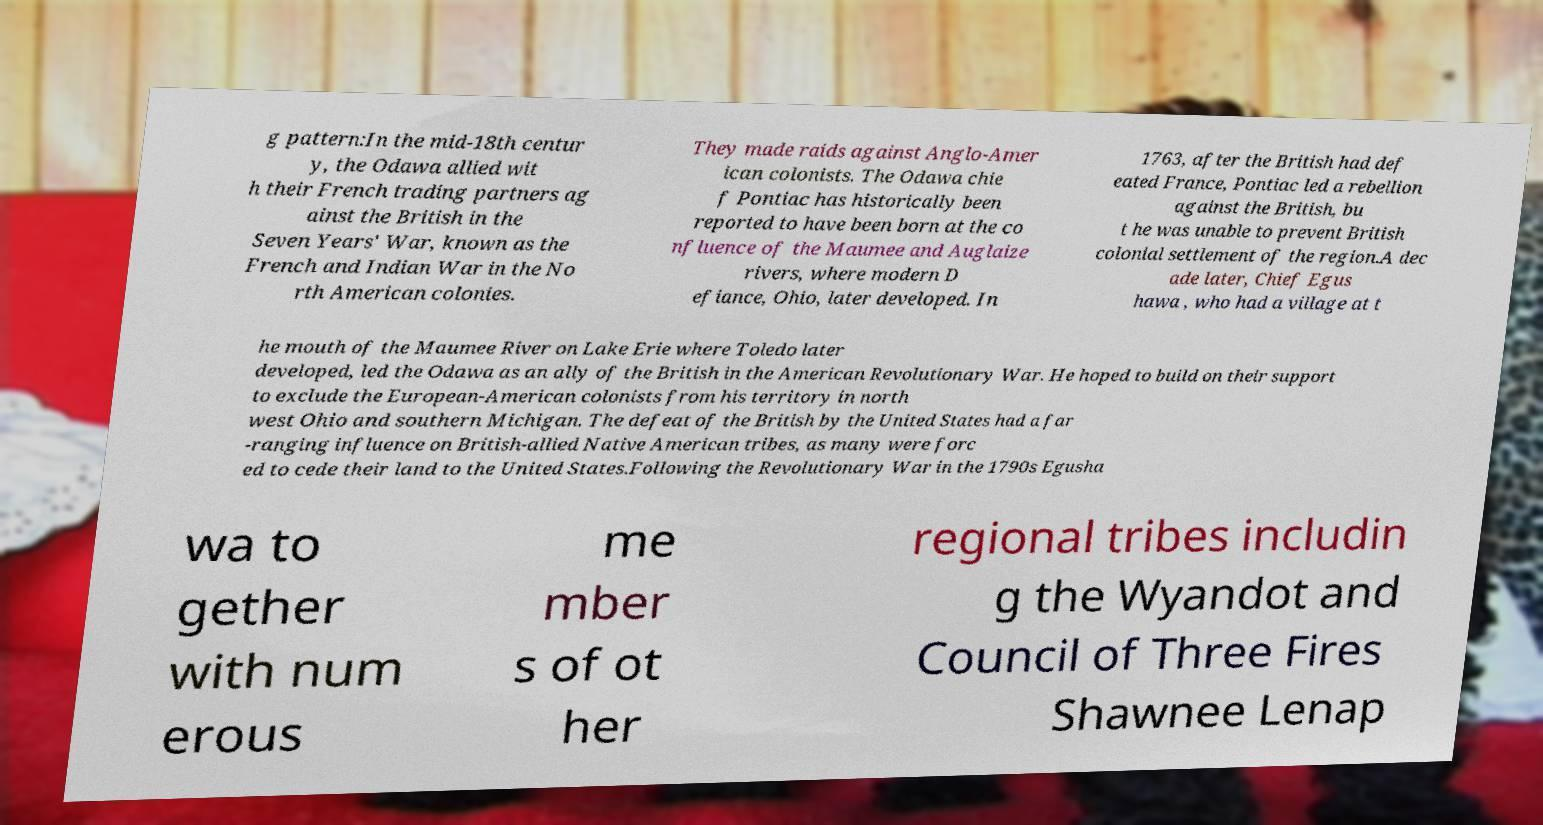There's text embedded in this image that I need extracted. Can you transcribe it verbatim? g pattern:In the mid-18th centur y, the Odawa allied wit h their French trading partners ag ainst the British in the Seven Years' War, known as the French and Indian War in the No rth American colonies. They made raids against Anglo-Amer ican colonists. The Odawa chie f Pontiac has historically been reported to have been born at the co nfluence of the Maumee and Auglaize rivers, where modern D efiance, Ohio, later developed. In 1763, after the British had def eated France, Pontiac led a rebellion against the British, bu t he was unable to prevent British colonial settlement of the region.A dec ade later, Chief Egus hawa , who had a village at t he mouth of the Maumee River on Lake Erie where Toledo later developed, led the Odawa as an ally of the British in the American Revolutionary War. He hoped to build on their support to exclude the European-American colonists from his territory in north west Ohio and southern Michigan. The defeat of the British by the United States had a far -ranging influence on British-allied Native American tribes, as many were forc ed to cede their land to the United States.Following the Revolutionary War in the 1790s Egusha wa to gether with num erous me mber s of ot her regional tribes includin g the Wyandot and Council of Three Fires Shawnee Lenap 